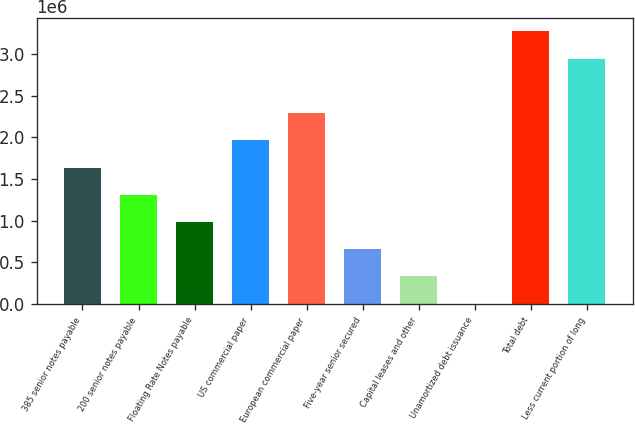<chart> <loc_0><loc_0><loc_500><loc_500><bar_chart><fcel>385 senior notes payable<fcel>200 senior notes payable<fcel>Floating Rate Notes payable<fcel>US commercial paper<fcel>European commercial paper<fcel>Five-year senior secured<fcel>Capital leases and other<fcel>Unamortized debt issuance<fcel>Total debt<fcel>Less current portion of long<nl><fcel>1.63918e+06<fcel>1.31237e+06<fcel>985569<fcel>1.96598e+06<fcel>2.29279e+06<fcel>658765<fcel>331960<fcel>5155<fcel>3.2732e+06<fcel>2.9464e+06<nl></chart> 